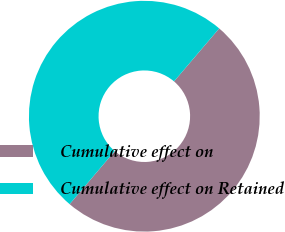Convert chart to OTSL. <chart><loc_0><loc_0><loc_500><loc_500><pie_chart><fcel>Cumulative effect on<fcel>Cumulative effect on Retained<nl><fcel>49.97%<fcel>50.03%<nl></chart> 